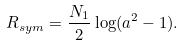Convert formula to latex. <formula><loc_0><loc_0><loc_500><loc_500>R _ { s y m } = \frac { N _ { 1 } } { 2 } \log ( a ^ { 2 } - 1 ) .</formula> 